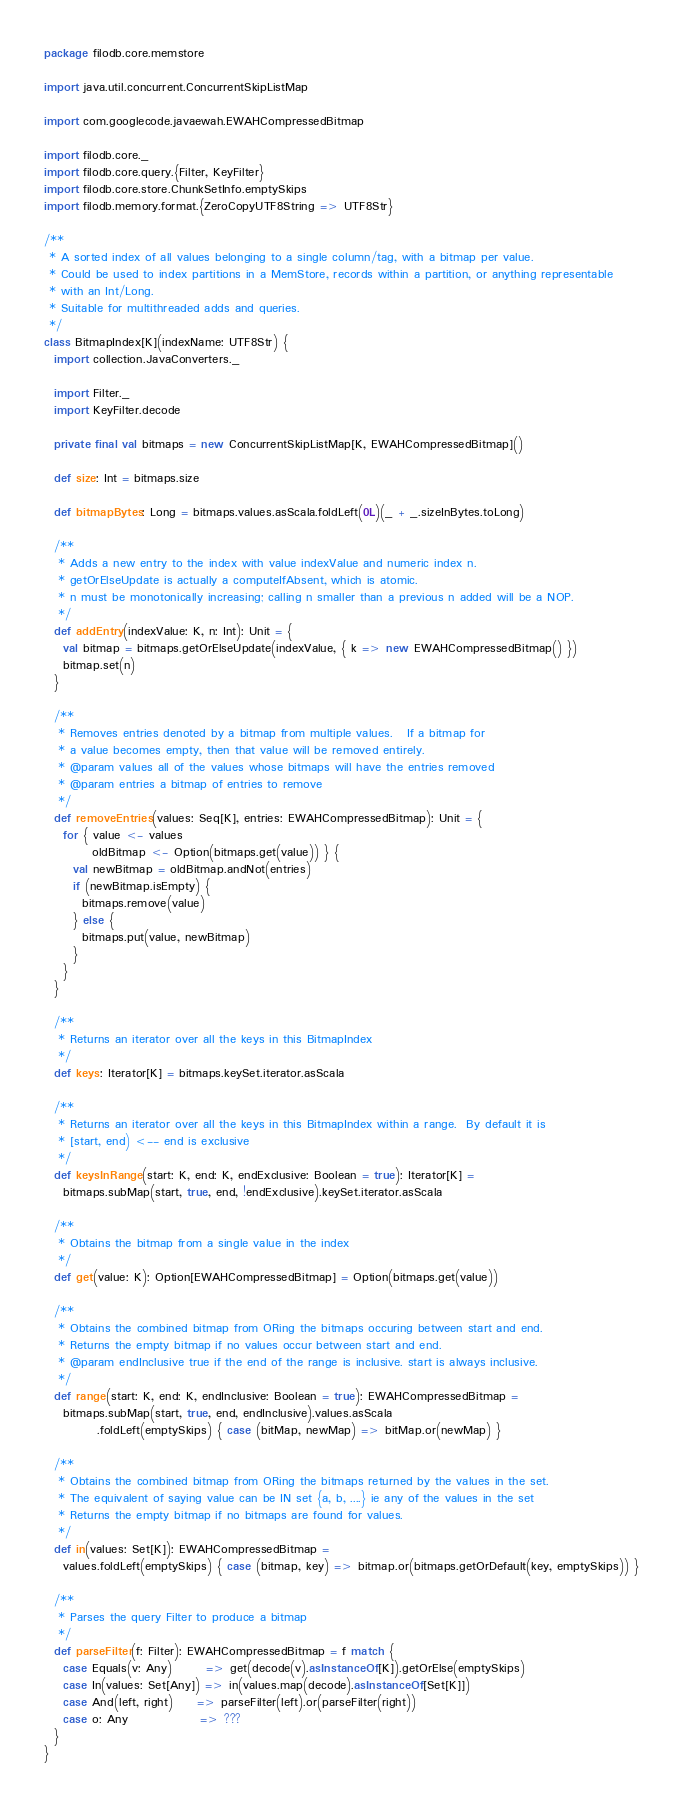<code> <loc_0><loc_0><loc_500><loc_500><_Scala_>package filodb.core.memstore

import java.util.concurrent.ConcurrentSkipListMap

import com.googlecode.javaewah.EWAHCompressedBitmap

import filodb.core._
import filodb.core.query.{Filter, KeyFilter}
import filodb.core.store.ChunkSetInfo.emptySkips
import filodb.memory.format.{ZeroCopyUTF8String => UTF8Str}

/**
 * A sorted index of all values belonging to a single column/tag, with a bitmap per value.
 * Could be used to index partitions in a MemStore, records within a partition, or anything representable
 * with an Int/Long.
 * Suitable for multithreaded adds and queries.
 */
class BitmapIndex[K](indexName: UTF8Str) {
  import collection.JavaConverters._

  import Filter._
  import KeyFilter.decode

  private final val bitmaps = new ConcurrentSkipListMap[K, EWAHCompressedBitmap]()

  def size: Int = bitmaps.size

  def bitmapBytes: Long = bitmaps.values.asScala.foldLeft(0L)(_ + _.sizeInBytes.toLong)

  /**
   * Adds a new entry to the index with value indexValue and numeric index n.
   * getOrElseUpdate is actually a computeIfAbsent, which is atomic.
   * n must be monotonically increasing; calling n smaller than a previous n added will be a NOP.
   */
  def addEntry(indexValue: K, n: Int): Unit = {
    val bitmap = bitmaps.getOrElseUpdate(indexValue, { k => new EWAHCompressedBitmap() })
    bitmap.set(n)
  }

  /**
   * Removes entries denoted by a bitmap from multiple values.   If a bitmap for
   * a value becomes empty, then that value will be removed entirely.
   * @param values all of the values whose bitmaps will have the entries removed
   * @param entries a bitmap of entries to remove
   */
  def removeEntries(values: Seq[K], entries: EWAHCompressedBitmap): Unit = {
    for { value <- values
          oldBitmap <- Option(bitmaps.get(value)) } {
      val newBitmap = oldBitmap.andNot(entries)
      if (newBitmap.isEmpty) {
        bitmaps.remove(value)
      } else {
        bitmaps.put(value, newBitmap)
      }
    }
  }

  /**
   * Returns an iterator over all the keys in this BitmapIndex
   */
  def keys: Iterator[K] = bitmaps.keySet.iterator.asScala

  /**
   * Returns an iterator over all the keys in this BitmapIndex within a range.  By default it is
   * [start, end) <-- end is exclusive
   */
  def keysInRange(start: K, end: K, endExclusive: Boolean = true): Iterator[K] =
    bitmaps.subMap(start, true, end, !endExclusive).keySet.iterator.asScala

  /**
   * Obtains the bitmap from a single value in the index
   */
  def get(value: K): Option[EWAHCompressedBitmap] = Option(bitmaps.get(value))

  /**
   * Obtains the combined bitmap from ORing the bitmaps occuring between start and end.
   * Returns the empty bitmap if no values occur between start and end.
   * @param endInclusive true if the end of the range is inclusive. start is always inclusive.
   */
  def range(start: K, end: K, endInclusive: Boolean = true): EWAHCompressedBitmap =
    bitmaps.subMap(start, true, end, endInclusive).values.asScala
           .foldLeft(emptySkips) { case (bitMap, newMap) => bitMap.or(newMap) }

  /**
   * Obtains the combined bitmap from ORing the bitmaps returned by the values in the set.
   * The equivalent of saying value can be IN set {a, b, ....} ie any of the values in the set
   * Returns the empty bitmap if no bitmaps are found for values.
   */
  def in(values: Set[K]): EWAHCompressedBitmap =
    values.foldLeft(emptySkips) { case (bitmap, key) => bitmap.or(bitmaps.getOrDefault(key, emptySkips)) }

  /**
   * Parses the query Filter to produce a bitmap
   */
  def parseFilter(f: Filter): EWAHCompressedBitmap = f match {
    case Equals(v: Any)       => get(decode(v).asInstanceOf[K]).getOrElse(emptySkips)
    case In(values: Set[Any]) => in(values.map(decode).asInstanceOf[Set[K]])
    case And(left, right)     => parseFilter(left).or(parseFilter(right))
    case o: Any               => ???
  }
}</code> 